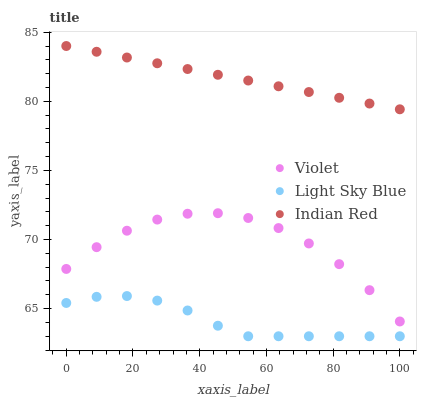Does Light Sky Blue have the minimum area under the curve?
Answer yes or no. Yes. Does Indian Red have the maximum area under the curve?
Answer yes or no. Yes. Does Violet have the minimum area under the curve?
Answer yes or no. No. Does Violet have the maximum area under the curve?
Answer yes or no. No. Is Indian Red the smoothest?
Answer yes or no. Yes. Is Violet the roughest?
Answer yes or no. Yes. Is Violet the smoothest?
Answer yes or no. No. Is Indian Red the roughest?
Answer yes or no. No. Does Light Sky Blue have the lowest value?
Answer yes or no. Yes. Does Violet have the lowest value?
Answer yes or no. No. Does Indian Red have the highest value?
Answer yes or no. Yes. Does Violet have the highest value?
Answer yes or no. No. Is Violet less than Indian Red?
Answer yes or no. Yes. Is Indian Red greater than Light Sky Blue?
Answer yes or no. Yes. Does Violet intersect Indian Red?
Answer yes or no. No. 